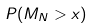<formula> <loc_0><loc_0><loc_500><loc_500>P ( M _ { N } > x )</formula> 